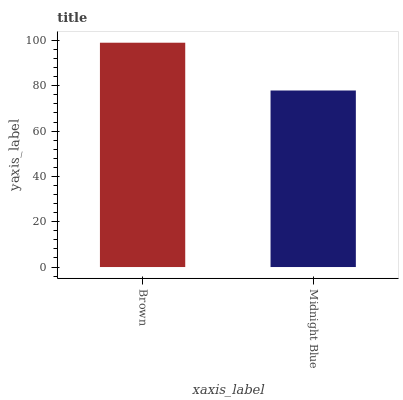Is Midnight Blue the minimum?
Answer yes or no. Yes. Is Brown the maximum?
Answer yes or no. Yes. Is Midnight Blue the maximum?
Answer yes or no. No. Is Brown greater than Midnight Blue?
Answer yes or no. Yes. Is Midnight Blue less than Brown?
Answer yes or no. Yes. Is Midnight Blue greater than Brown?
Answer yes or no. No. Is Brown less than Midnight Blue?
Answer yes or no. No. Is Brown the high median?
Answer yes or no. Yes. Is Midnight Blue the low median?
Answer yes or no. Yes. Is Midnight Blue the high median?
Answer yes or no. No. Is Brown the low median?
Answer yes or no. No. 